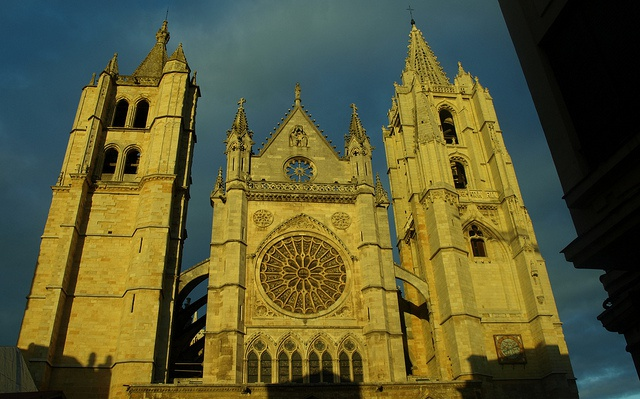Describe the objects in this image and their specific colors. I can see a clock in blue, olive, black, and maroon tones in this image. 